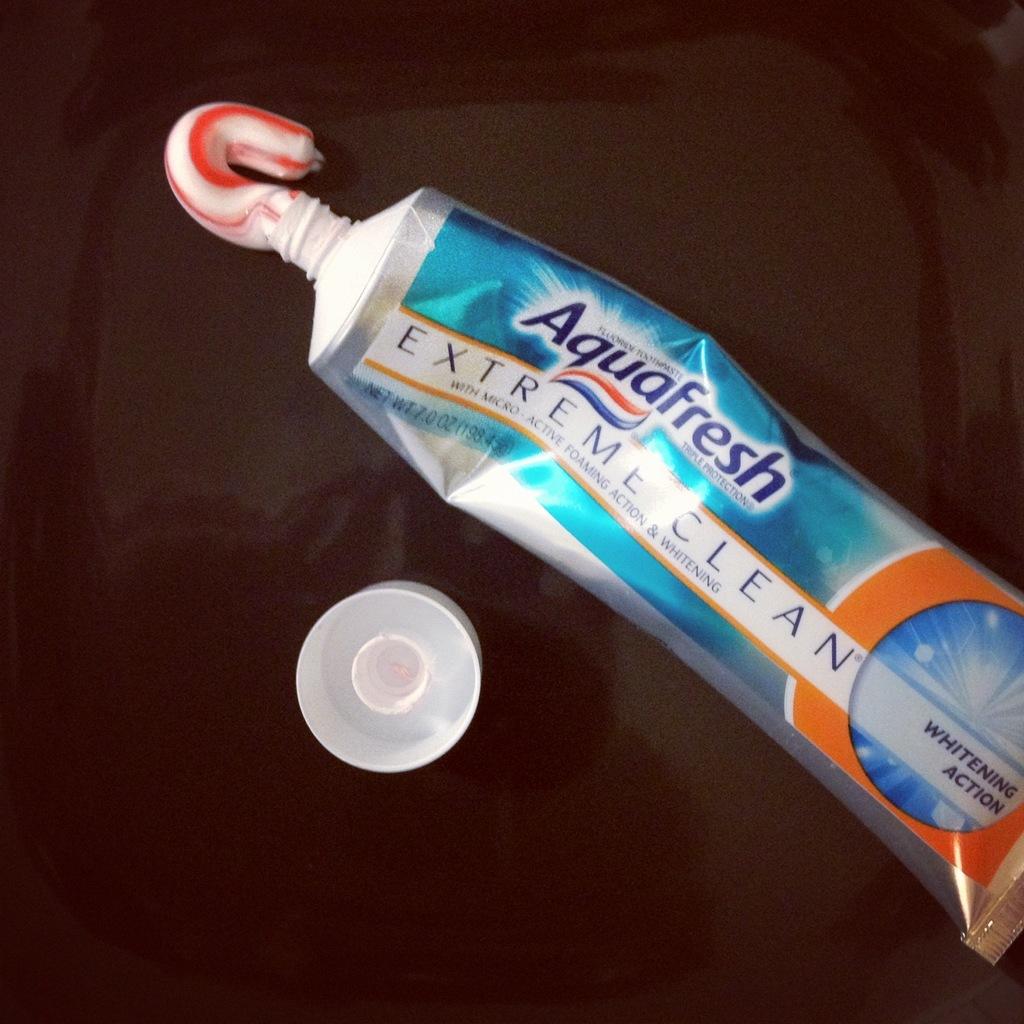What is the brand name of the toothpaste?
Your answer should be compact. Aquafresh. 